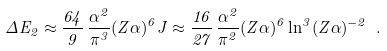Convert formula to latex. <formula><loc_0><loc_0><loc_500><loc_500>\Delta E _ { 2 } \approx \frac { 6 4 } { 9 } \, \frac { \alpha ^ { 2 } } { \pi ^ { 3 } } ( Z \alpha ) ^ { 6 } J \approx \frac { 1 6 } { 2 7 } \, \frac { \alpha ^ { 2 } } { \pi ^ { 2 } } ( Z \alpha ) ^ { 6 } \ln ^ { 3 } ( Z \alpha ) ^ { - 2 } \ .</formula> 